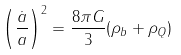Convert formula to latex. <formula><loc_0><loc_0><loc_500><loc_500>\left ( \frac { \dot { a } } { a } \right ) ^ { 2 } = \frac { 8 \pi G } { 3 } ( \rho _ { b } + \rho _ { Q } )</formula> 